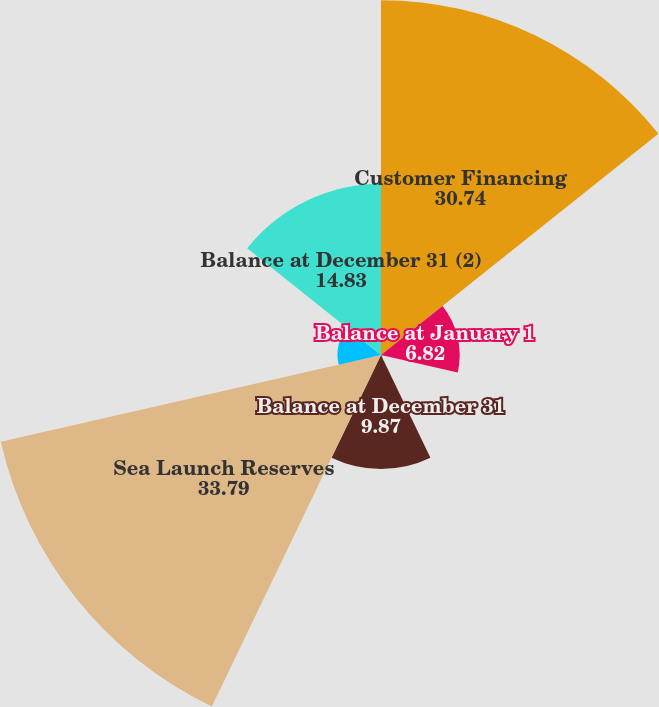Convert chart. <chart><loc_0><loc_0><loc_500><loc_500><pie_chart><fcel>Customer Financing<fcel>Balance at January 1<fcel>Deductions from reserves<fcel>Balance at December 31<fcel>Sea Launch Reserves<fcel>Additions (1)<fcel>Balance at December 31 (2)<nl><fcel>30.74%<fcel>6.82%<fcel>0.18%<fcel>9.87%<fcel>33.79%<fcel>3.76%<fcel>14.83%<nl></chart> 